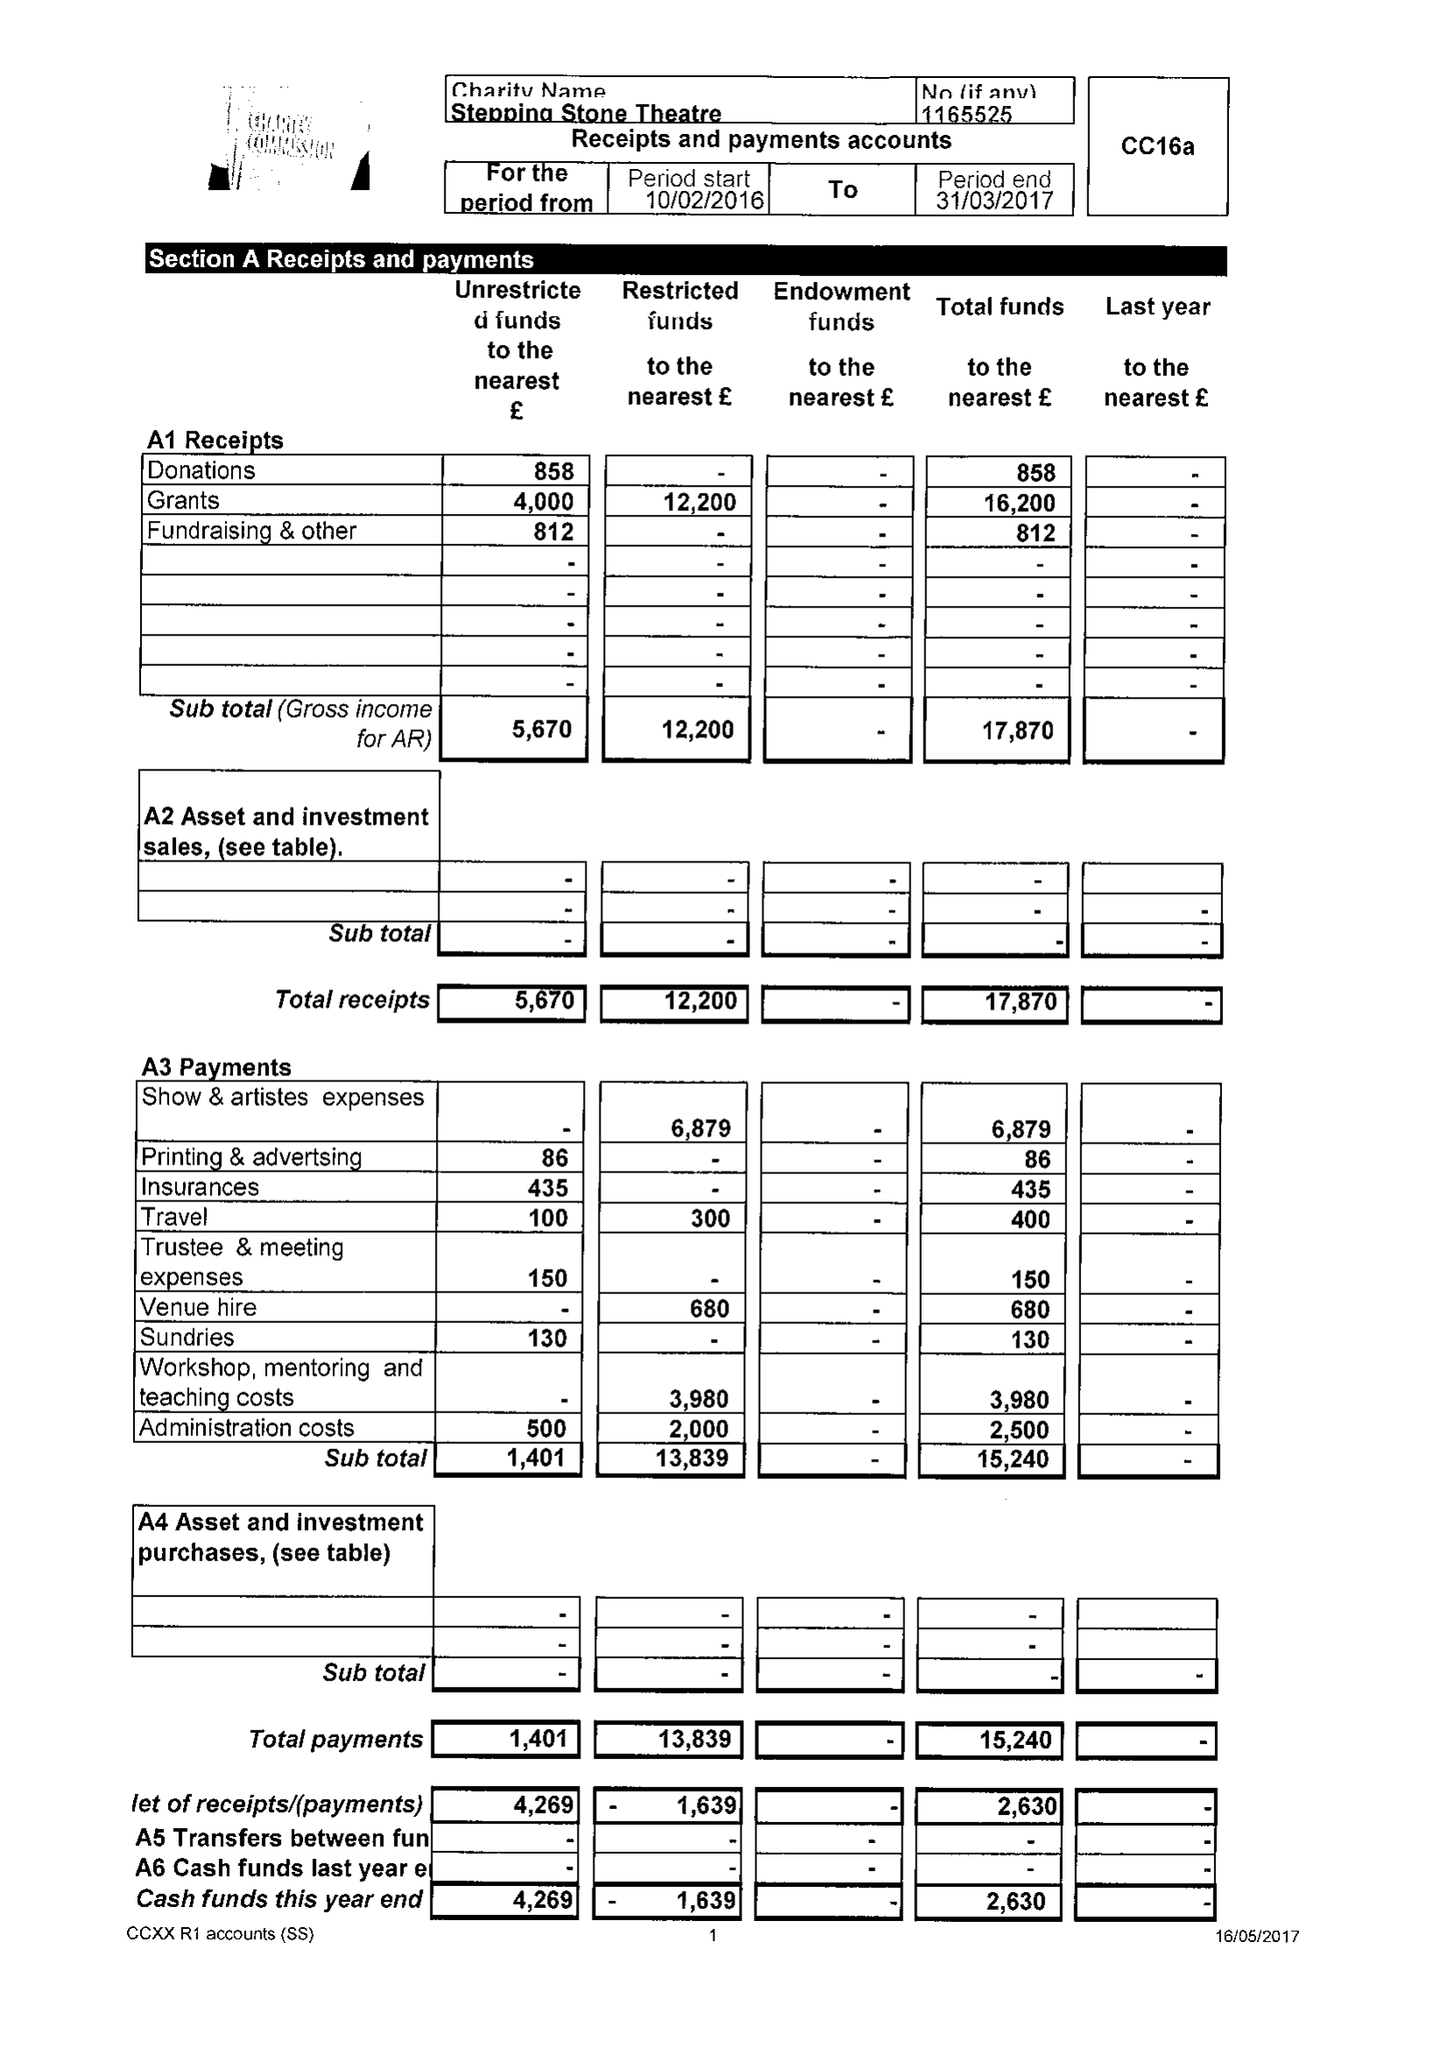What is the value for the spending_annually_in_british_pounds?
Answer the question using a single word or phrase. 15240.00 